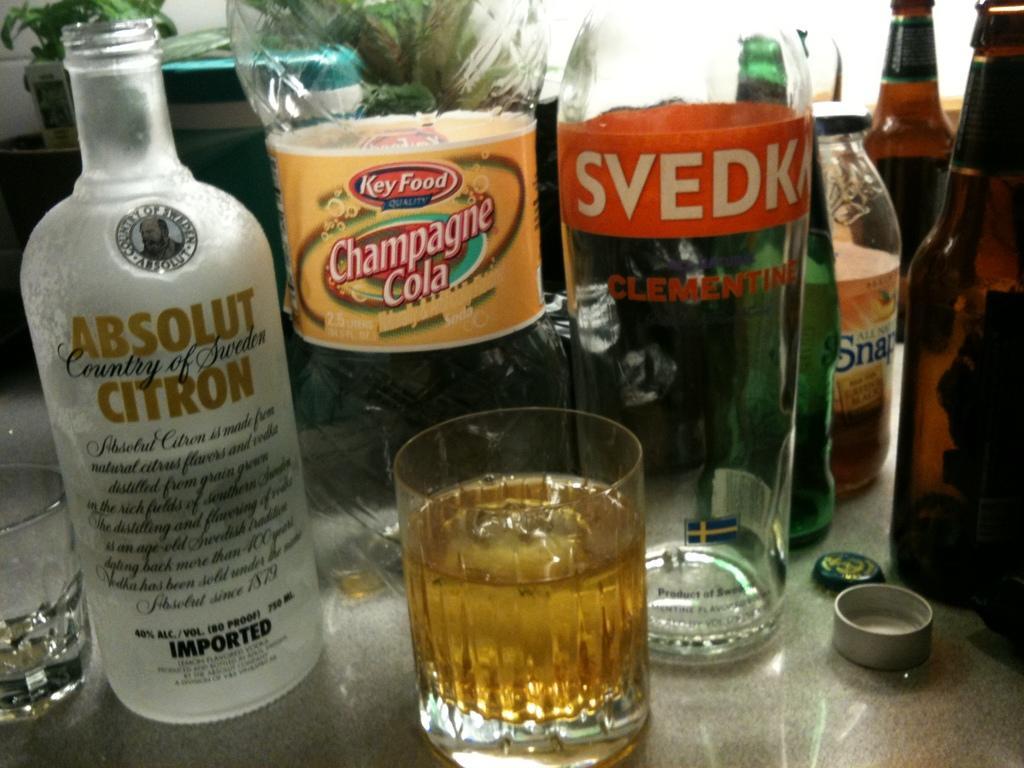Describe this image in one or two sentences. In this picture, this is a table on the table there are glass with liquid, bottles, caps, box and house plant. 